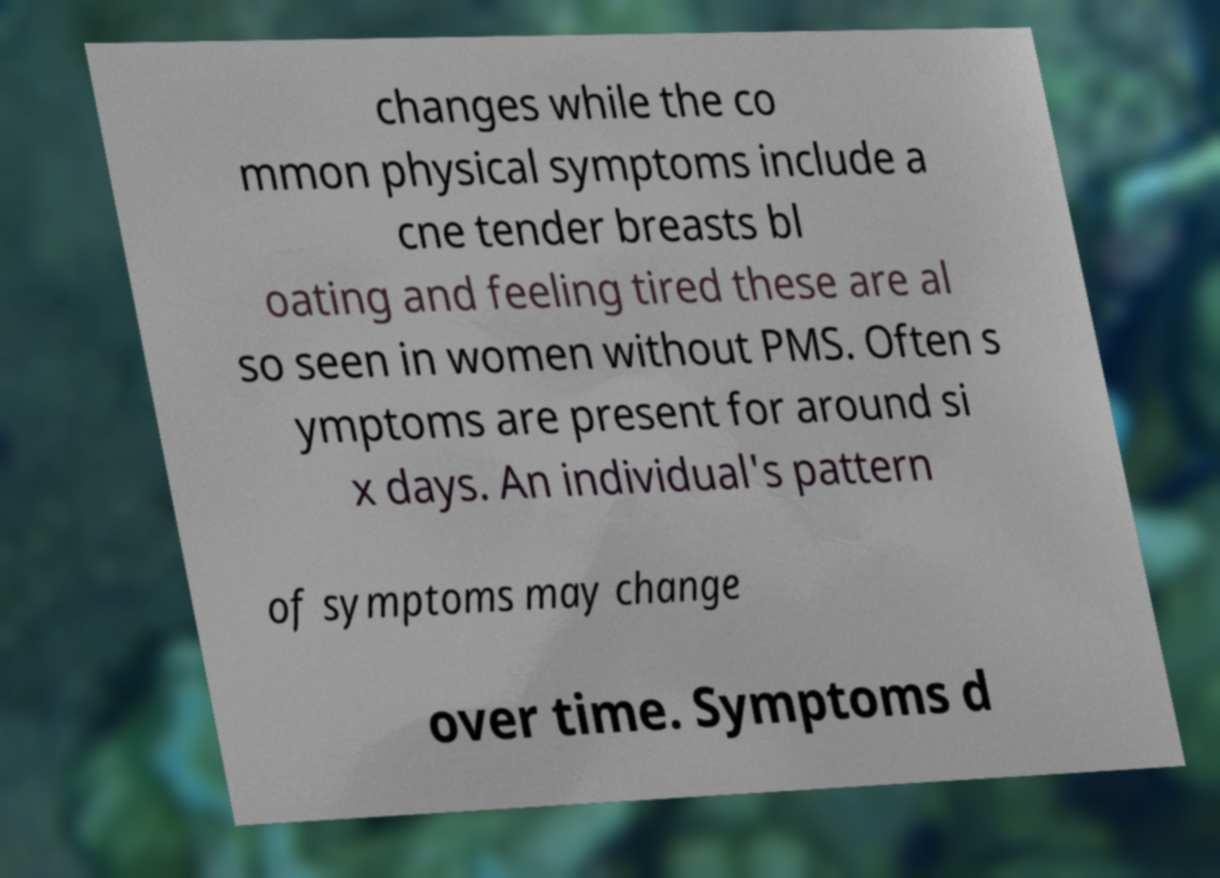Could you assist in decoding the text presented in this image and type it out clearly? changes while the co mmon physical symptoms include a cne tender breasts bl oating and feeling tired these are al so seen in women without PMS. Often s ymptoms are present for around si x days. An individual's pattern of symptoms may change over time. Symptoms d 